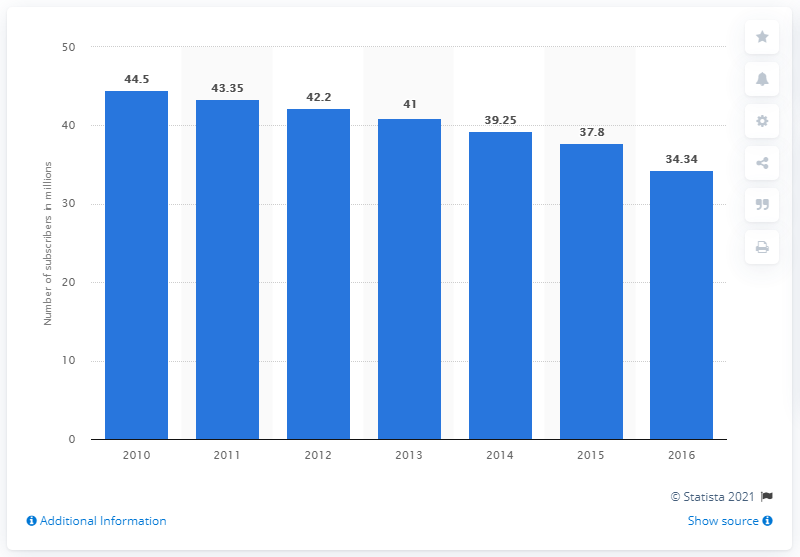Identify some key points in this picture. In 2016, there were approximately 34.34 cable subscribers in the United States. 